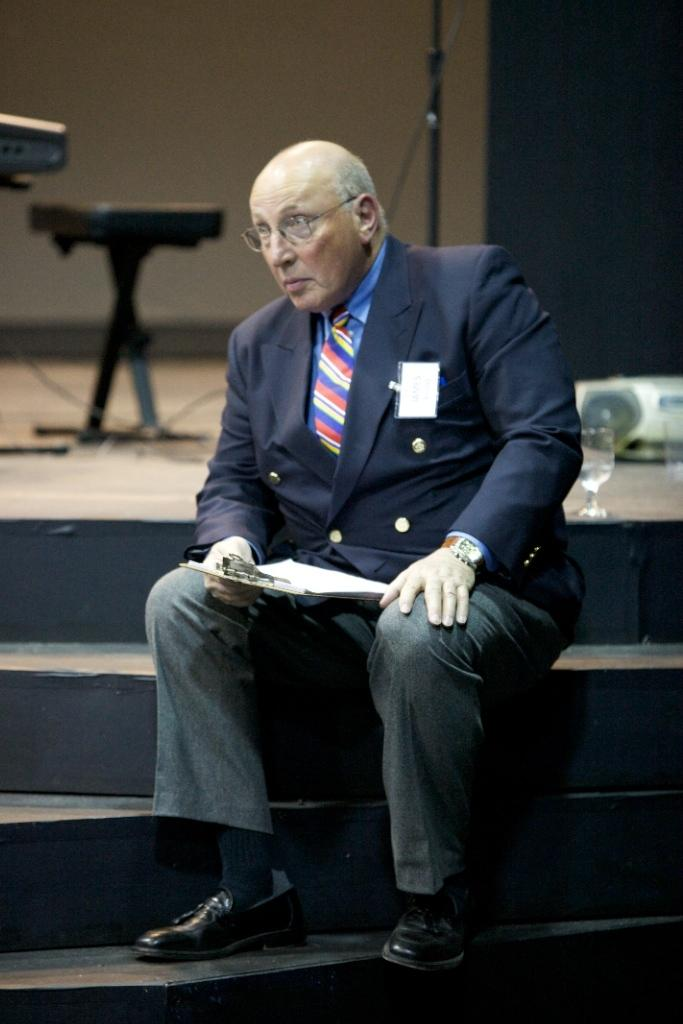What is the person in the image doing? The person is sitting on the stairs. What is the person holding in the image? The person is holding a book. What object is beside the person? There is a glass beside the person. What can be seen in the background of the image? There is a chair and a microphone (mike) in the background. What type of crayon is the person using to draw attention in the image? There is no crayon or drawing activity present in the image. 